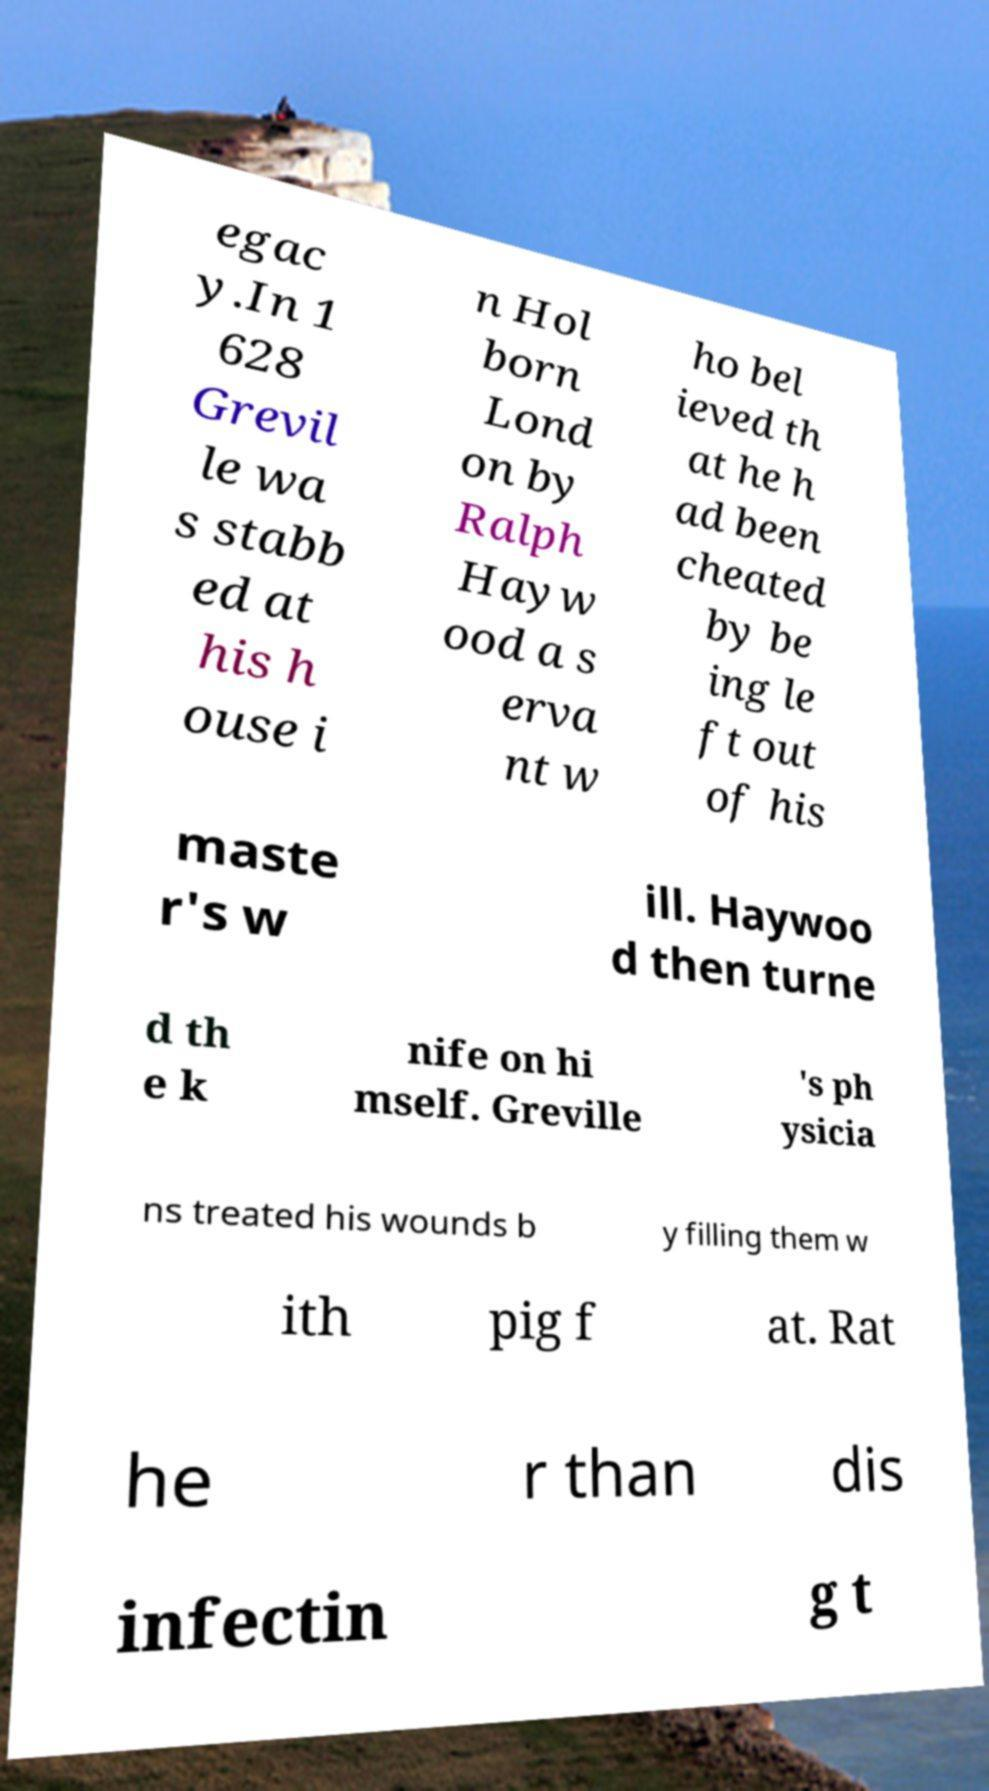What messages or text are displayed in this image? I need them in a readable, typed format. egac y.In 1 628 Grevil le wa s stabb ed at his h ouse i n Hol born Lond on by Ralph Hayw ood a s erva nt w ho bel ieved th at he h ad been cheated by be ing le ft out of his maste r's w ill. Haywoo d then turne d th e k nife on hi mself. Greville 's ph ysicia ns treated his wounds b y filling them w ith pig f at. Rat he r than dis infectin g t 